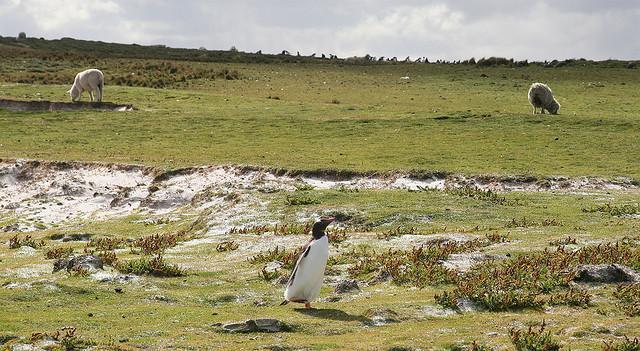How many spoons are in this broccoli dish?
Give a very brief answer. 0. 